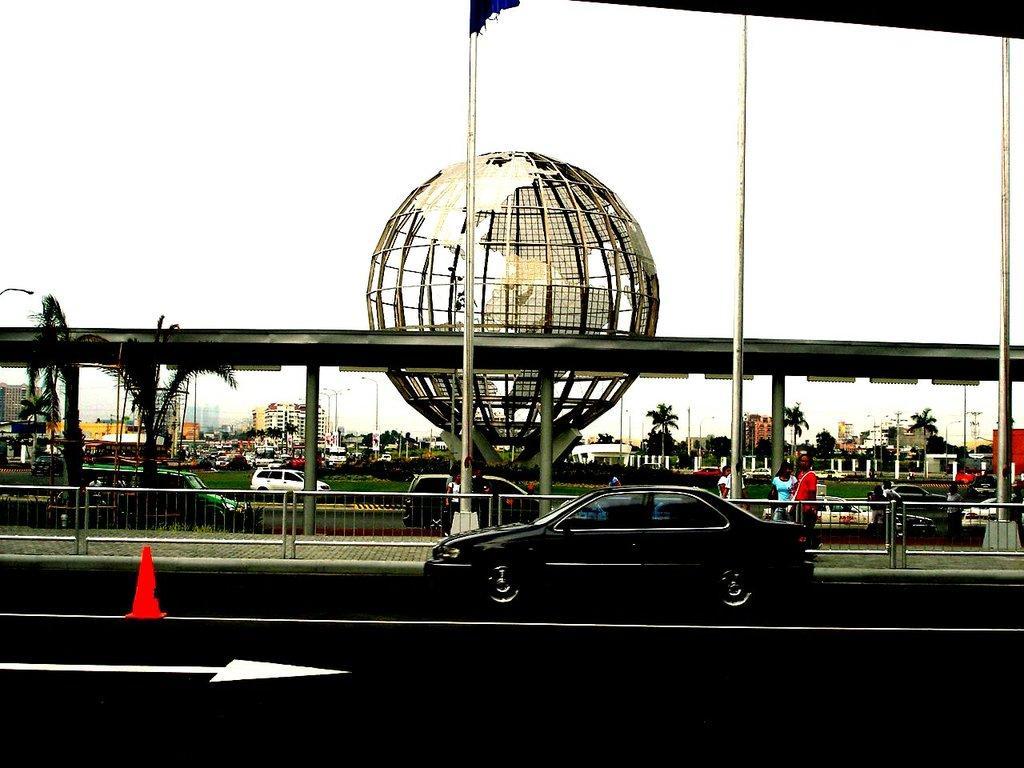Please provide a concise description of this image. At the bottom of the image on the road there is a car and also there is a traffic cone. Behind the car there is a footpath with railings and also there are few people. Behind them there are vehicles and also there are trees, buildings and poles. And there is an object like a globe. 